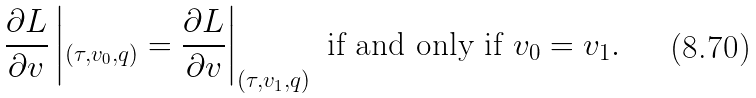<formula> <loc_0><loc_0><loc_500><loc_500>\frac { \partial L } { \partial v } \left | _ { ( \tau , v _ { 0 } , q ) } = \frac { \partial L } { \partial v } \right | _ { ( \tau , v _ { 1 } , q ) } \text { if and only if } v _ { 0 } = v _ { 1 } .</formula> 